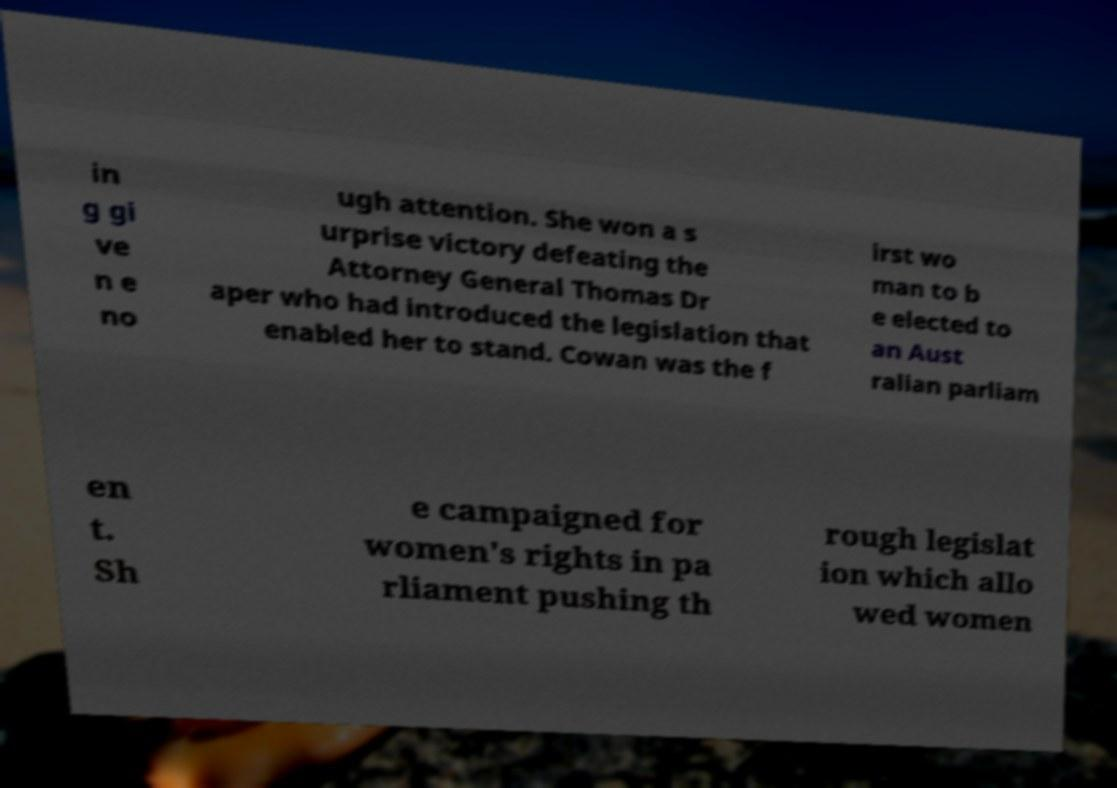Please read and relay the text visible in this image. What does it say? in g gi ve n e no ugh attention. She won a s urprise victory defeating the Attorney General Thomas Dr aper who had introduced the legislation that enabled her to stand. Cowan was the f irst wo man to b e elected to an Aust ralian parliam en t. Sh e campaigned for women's rights in pa rliament pushing th rough legislat ion which allo wed women 